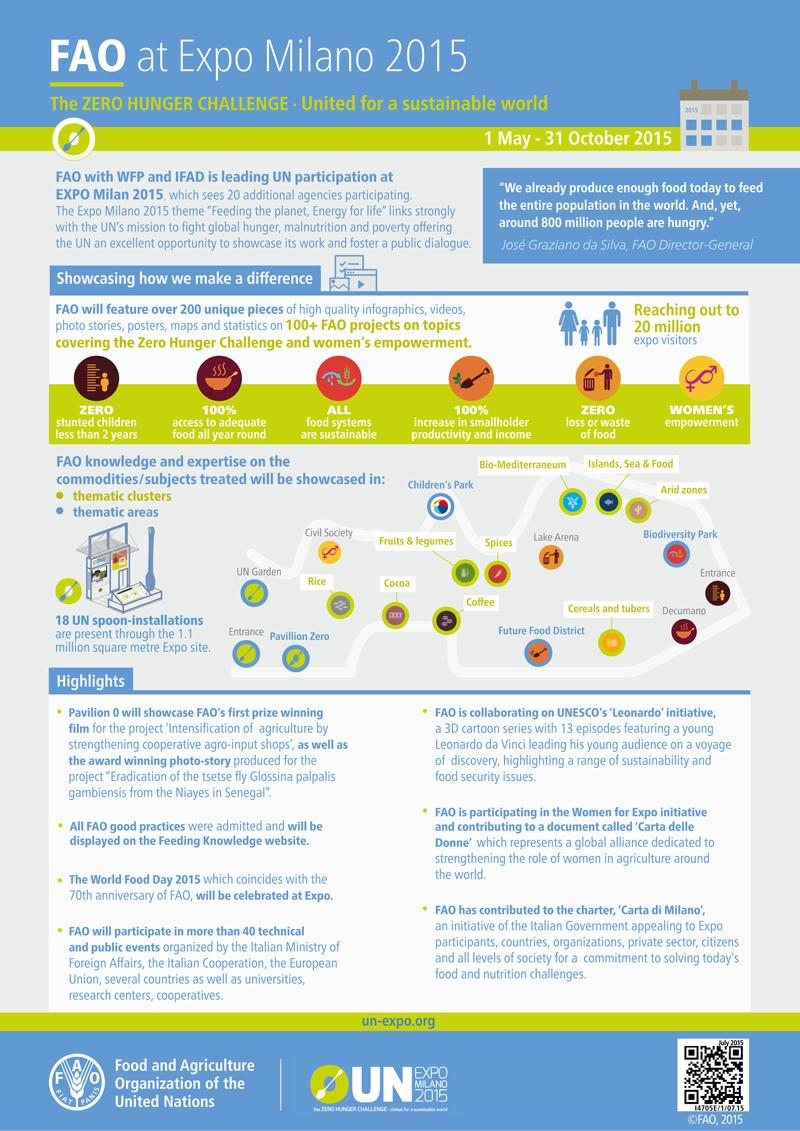Indicate a few pertinent items in this graphic. There were 18 UN spoon installations at the Expo Milano 2015. Expo Milano 2015 covered an area of 1.1 million square meters. The Expo Milano 2015 was visited by approximately 20 million people. According to the FAO, the expected percentage increase in smallholder productivity and income is projected to be 100%. 